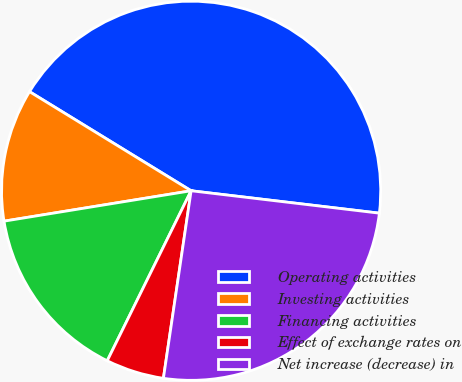Convert chart. <chart><loc_0><loc_0><loc_500><loc_500><pie_chart><fcel>Operating activities<fcel>Investing activities<fcel>Financing activities<fcel>Effect of exchange rates on<fcel>Net increase (decrease) in<nl><fcel>43.13%<fcel>11.32%<fcel>15.14%<fcel>4.96%<fcel>25.45%<nl></chart> 